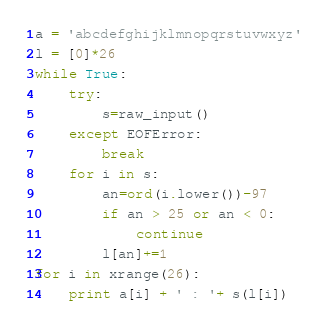<code> <loc_0><loc_0><loc_500><loc_500><_Python_>a = 'abcdefghijklmnopqrstuvwxyz'
l = [0]*26
while True:
    try:
        s=raw_input()
    except EOFError:
        break
    for i in s:
        an=ord(i.lower())-97
        if an > 25 or an < 0:
            continue
        l[an]+=1
for i in xrange(26):
    print a[i] + ' : '+ s(l[i])</code> 